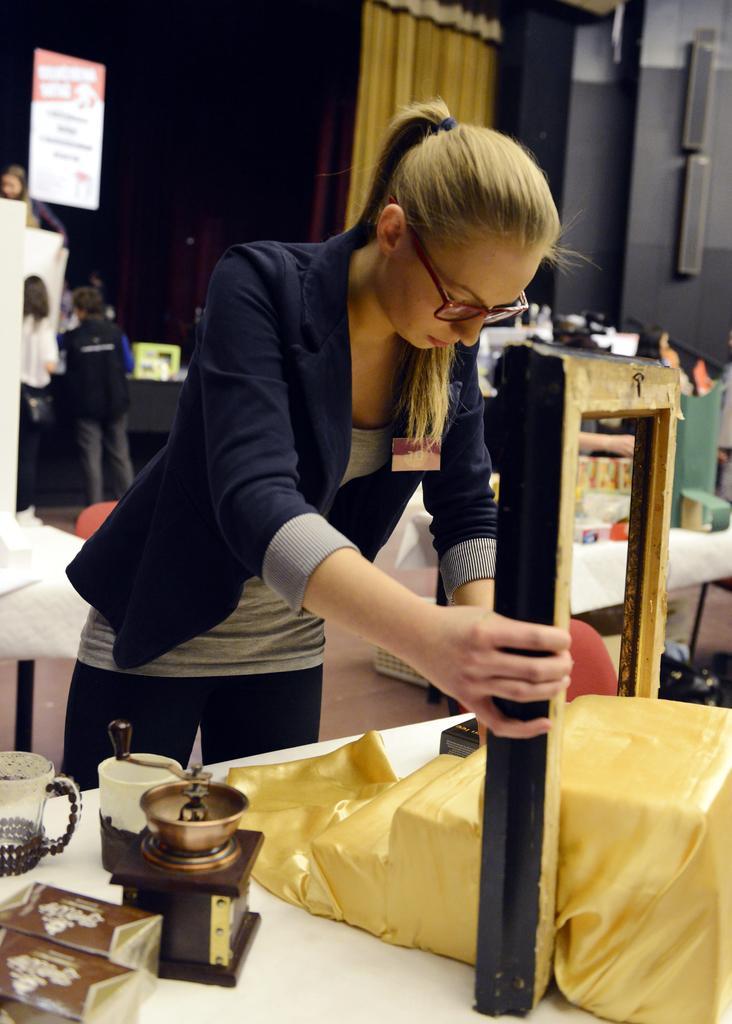How would you summarize this image in a sentence or two? This picture is clicked inside. In the center there is a woman standing on the ground and holding a wooden object. In the foreground there is a table on the top of which a cup, box and many number of items are placed. In the background we can see the curtain, wall, group of persons, banner and many number of objects. 